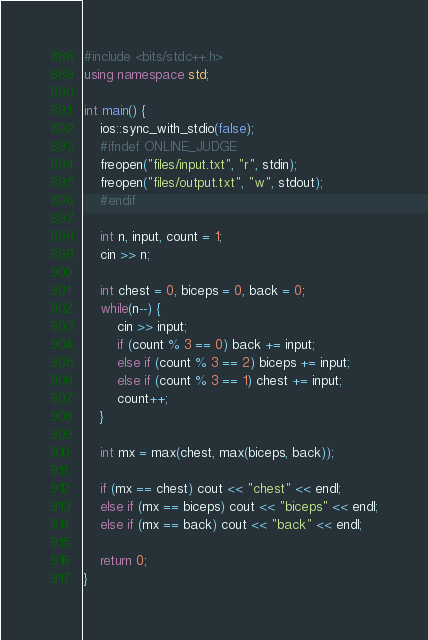Convert code to text. <code><loc_0><loc_0><loc_500><loc_500><_C++_>#include <bits/stdc++.h>
using namespace std;

int main() {
    ios::sync_with_stdio(false);
    #ifndef ONLINE_JUDGE
    freopen("files/input.txt", "r", stdin);
    freopen("files/output.txt", "w", stdout);
    #endif

    int n, input, count = 1;
    cin >> n;

    int chest = 0, biceps = 0, back = 0;
    while(n--) {
        cin >> input;
        if (count % 3 == 0) back += input;
        else if (count % 3 == 2) biceps += input;
        else if (count % 3 == 1) chest += input;
        count++;
    }

    int mx = max(chest, max(biceps, back));

    if (mx == chest) cout << "chest" << endl;
    else if (mx == biceps) cout << "biceps" << endl;
    else if (mx == back) cout << "back" << endl;

    return 0;
}
</code> 